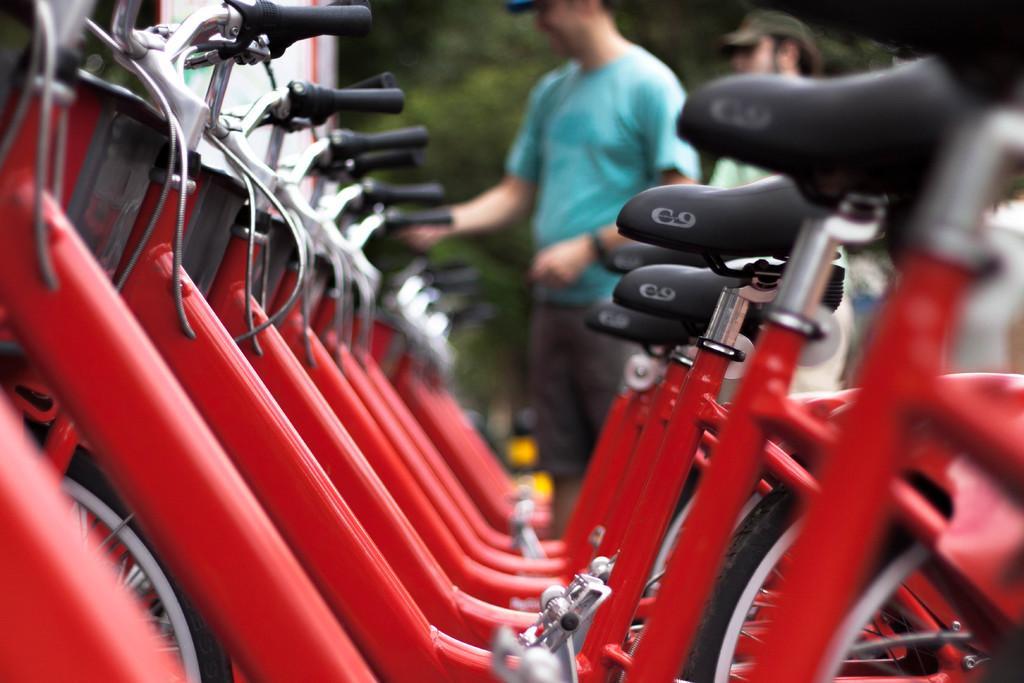How would you summarize this image in a sentence or two? This image is taken outdoors. In the middle of the image many bicycles are parked on the floor. In the background there are a few trees and two men are standing on the floor. 